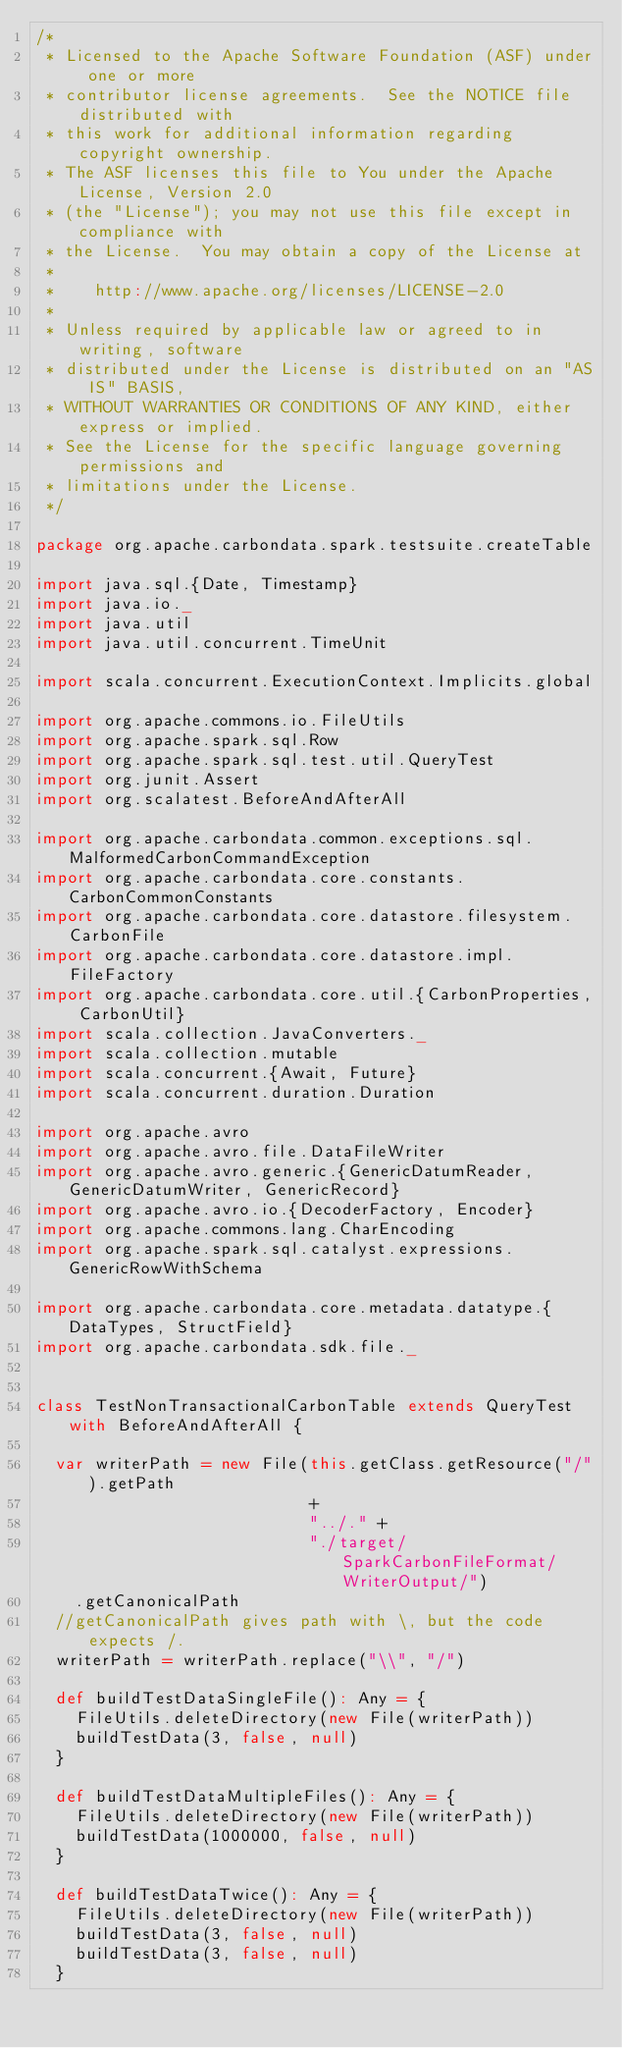Convert code to text. <code><loc_0><loc_0><loc_500><loc_500><_Scala_>/*
 * Licensed to the Apache Software Foundation (ASF) under one or more
 * contributor license agreements.  See the NOTICE file distributed with
 * this work for additional information regarding copyright ownership.
 * The ASF licenses this file to You under the Apache License, Version 2.0
 * (the "License"); you may not use this file except in compliance with
 * the License.  You may obtain a copy of the License at
 *
 *    http://www.apache.org/licenses/LICENSE-2.0
 *
 * Unless required by applicable law or agreed to in writing, software
 * distributed under the License is distributed on an "AS IS" BASIS,
 * WITHOUT WARRANTIES OR CONDITIONS OF ANY KIND, either express or implied.
 * See the License for the specific language governing permissions and
 * limitations under the License.
 */

package org.apache.carbondata.spark.testsuite.createTable

import java.sql.{Date, Timestamp}
import java.io._
import java.util
import java.util.concurrent.TimeUnit

import scala.concurrent.ExecutionContext.Implicits.global

import org.apache.commons.io.FileUtils
import org.apache.spark.sql.Row
import org.apache.spark.sql.test.util.QueryTest
import org.junit.Assert
import org.scalatest.BeforeAndAfterAll

import org.apache.carbondata.common.exceptions.sql.MalformedCarbonCommandException
import org.apache.carbondata.core.constants.CarbonCommonConstants
import org.apache.carbondata.core.datastore.filesystem.CarbonFile
import org.apache.carbondata.core.datastore.impl.FileFactory
import org.apache.carbondata.core.util.{CarbonProperties, CarbonUtil}
import scala.collection.JavaConverters._
import scala.collection.mutable
import scala.concurrent.{Await, Future}
import scala.concurrent.duration.Duration

import org.apache.avro
import org.apache.avro.file.DataFileWriter
import org.apache.avro.generic.{GenericDatumReader, GenericDatumWriter, GenericRecord}
import org.apache.avro.io.{DecoderFactory, Encoder}
import org.apache.commons.lang.CharEncoding
import org.apache.spark.sql.catalyst.expressions.GenericRowWithSchema

import org.apache.carbondata.core.metadata.datatype.{DataTypes, StructField}
import org.apache.carbondata.sdk.file._


class TestNonTransactionalCarbonTable extends QueryTest with BeforeAndAfterAll {

  var writerPath = new File(this.getClass.getResource("/").getPath
                            +
                            "../." +
                            "./target/SparkCarbonFileFormat/WriterOutput/")
    .getCanonicalPath
  //getCanonicalPath gives path with \, but the code expects /.
  writerPath = writerPath.replace("\\", "/")

  def buildTestDataSingleFile(): Any = {
    FileUtils.deleteDirectory(new File(writerPath))
    buildTestData(3, false, null)
  }

  def buildTestDataMultipleFiles(): Any = {
    FileUtils.deleteDirectory(new File(writerPath))
    buildTestData(1000000, false, null)
  }

  def buildTestDataTwice(): Any = {
    FileUtils.deleteDirectory(new File(writerPath))
    buildTestData(3, false, null)
    buildTestData(3, false, null)
  }
</code> 